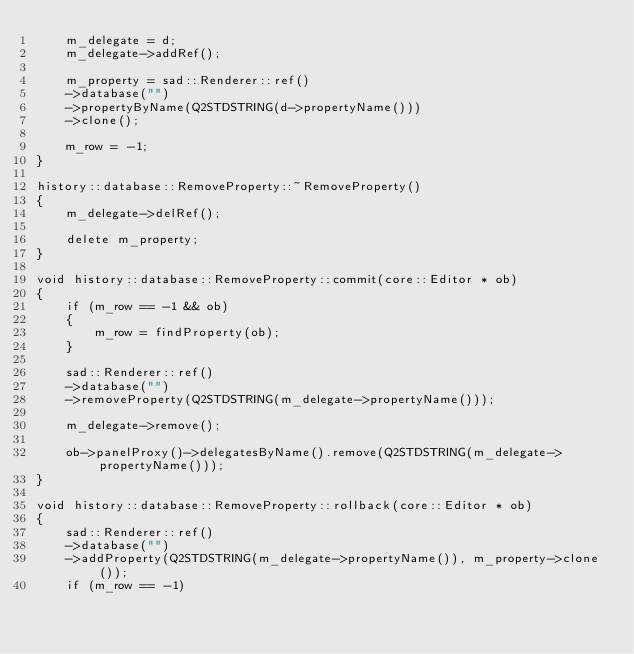<code> <loc_0><loc_0><loc_500><loc_500><_C++_>    m_delegate = d;
    m_delegate->addRef();

    m_property = sad::Renderer::ref()
    ->database("")
    ->propertyByName(Q2STDSTRING(d->propertyName()))
    ->clone();

    m_row = -1;    
}

history::database::RemoveProperty::~RemoveProperty()
{
    m_delegate->delRef();

    delete m_property;
}

void history::database::RemoveProperty::commit(core::Editor * ob)
{
    if (m_row == -1 && ob)
    {
        m_row = findProperty(ob);
    }

    sad::Renderer::ref()
    ->database("")
    ->removeProperty(Q2STDSTRING(m_delegate->propertyName()));
    
    m_delegate->remove();

    ob->panelProxy()->delegatesByName().remove(Q2STDSTRING(m_delegate->propertyName()));
}

void history::database::RemoveProperty::rollback(core::Editor * ob)
{
    sad::Renderer::ref()
    ->database("")
    ->addProperty(Q2STDSTRING(m_delegate->propertyName()), m_property->clone());
    if (m_row == -1)</code> 